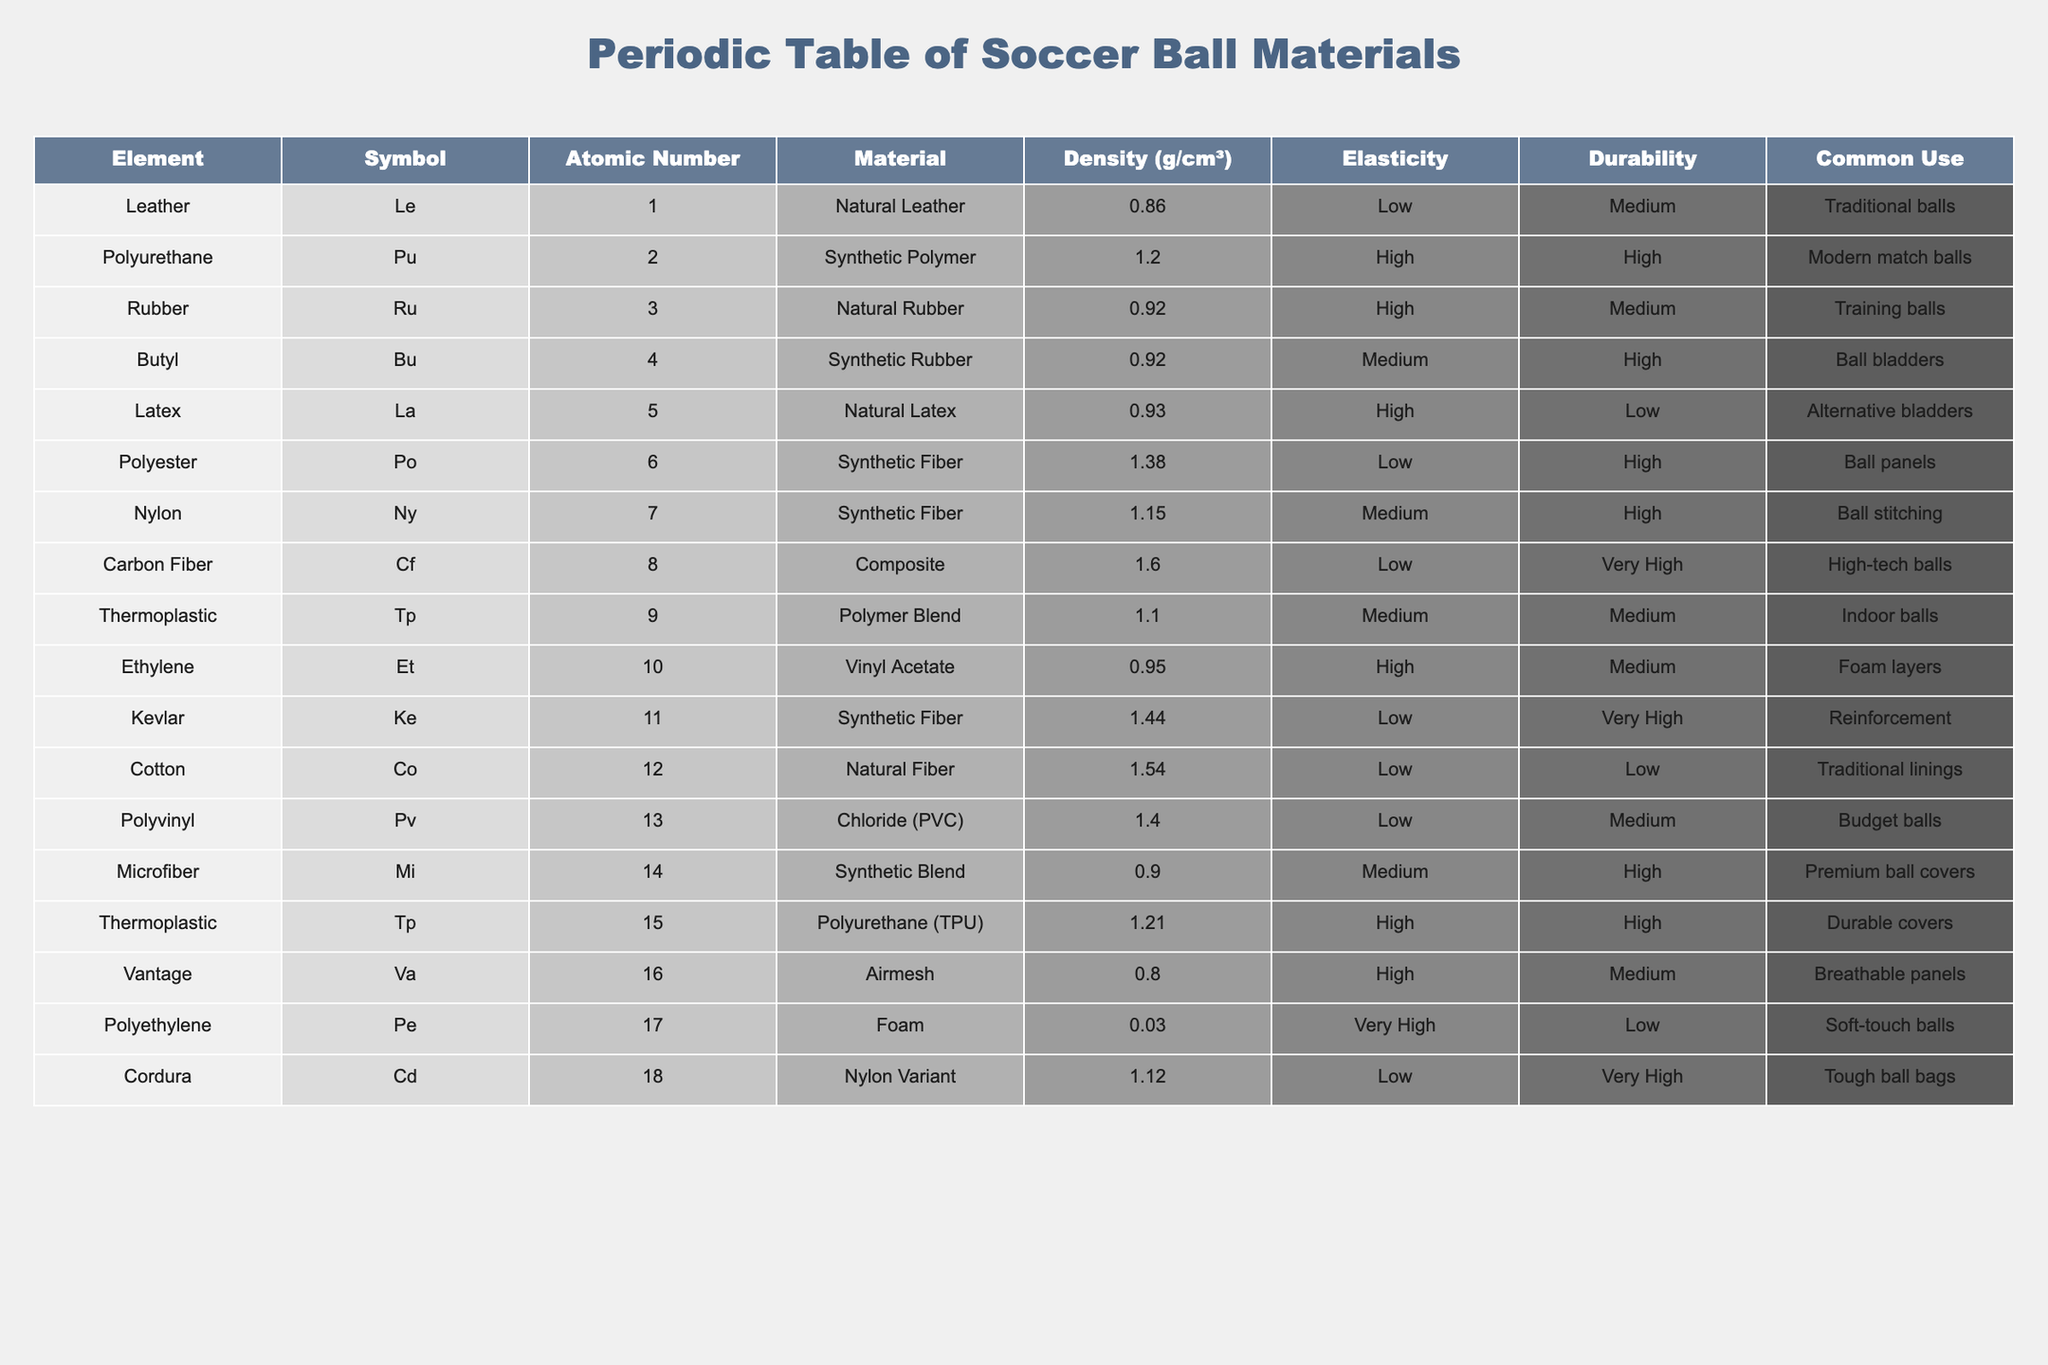What is the material with the highest density? The table shows the density for each material. By reviewing the 'Density' column, I see that Carbon Fiber, with a density of 1.6 g/cm³, has the highest density value among the listed materials.
Answer: Carbon Fiber Which material type has the lowest elasticity? I can check the 'Elasticity' column. The materials classified with 'Low' elasticity are Natural Leather, Carbon Fiber, Cotton, and Polyvinyl. Among these, Carbon Fiber is one of the materials with 'Low' elasticity.
Answer: Carbon Fiber How many materials are classified as Synthetic Fiber? In the table, I can see three materials marked as Synthetic Fiber: Polyester, Nylon, and Kevlar. Hence, counting them gives me a total of 3.
Answer: 3 What is the average density of Natural materials? I first need to identify the Natural materials from the table: Natural Leather (0.86), Natural Rubber (0.92), Natural Latex (0.93), and Cotton (1.54). I then sum their densities: 0.86 + 0.92 + 0.93 + 1.54 = 3.25. Since there are four materials, the average density will be 3.25 / 4 = 0.8125.
Answer: 0.8125 Is Polyurethane characterized as having high durability? By looking at the 'Durability' column, Polyurethane is marked as having 'High' durability, confirming the statement is true.
Answer: Yes Which two materials, when combined, give the highest density? I will find the two materials in the table with the highest densities, which are Carbon Fiber (1.6 g/cm³) and the next highest, which is Kevlar (1.44 g/cm³). Adding these together: 1.6 + 1.44 = 3.04 g/cm³.
Answer: 3.04 g/cm³ Are there any materials with 'Very High' durability? Checking the 'Durability' column indicates that both Butyl and Kevlar are categorized as 'Very High' in terms of durability. So, the answer to the question is yes.
Answer: Yes What is the most common use for Natural Rubber? Referring to the 'Common Use' column for Natural Rubber indicates that it's primarily used for training balls.
Answer: Training balls 